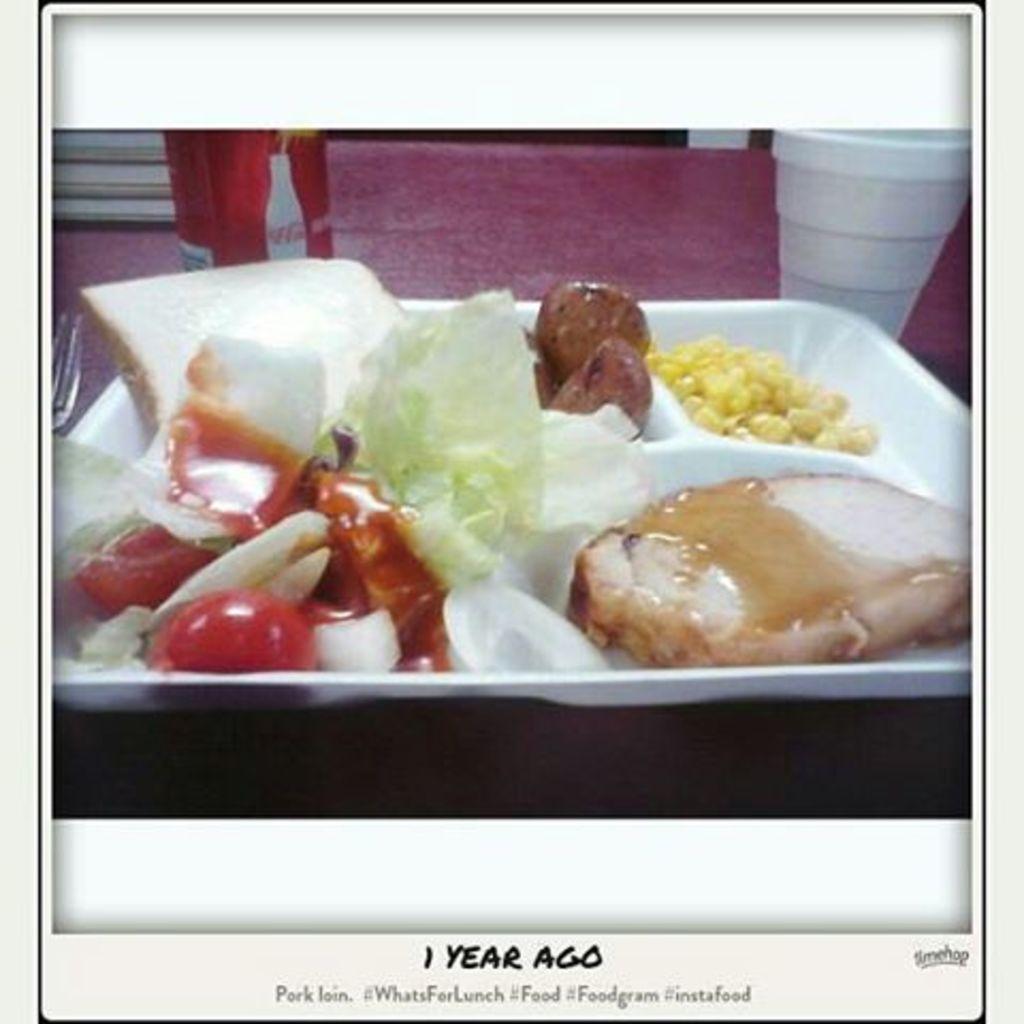Can you describe this image briefly? In this image there are food items on a plate. Beside the plate there is a tin. There is a cup, fork on the table. There is some text at the bottom of the image. 